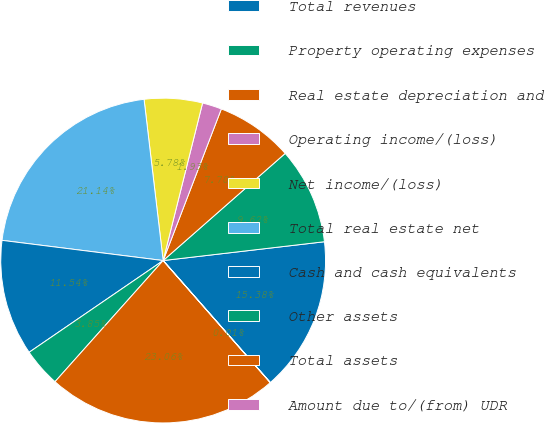Convert chart. <chart><loc_0><loc_0><loc_500><loc_500><pie_chart><fcel>Total revenues<fcel>Property operating expenses<fcel>Real estate depreciation and<fcel>Operating income/(loss)<fcel>Net income/(loss)<fcel>Total real estate net<fcel>Cash and cash equivalents<fcel>Other assets<fcel>Total assets<fcel>Amount due to/(from) UDR<nl><fcel>15.38%<fcel>9.62%<fcel>7.7%<fcel>1.93%<fcel>5.78%<fcel>21.14%<fcel>11.54%<fcel>3.85%<fcel>23.06%<fcel>0.01%<nl></chart> 